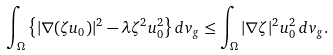Convert formula to latex. <formula><loc_0><loc_0><loc_500><loc_500>\int _ { \Omega } \left \{ | \nabla ( \zeta u _ { 0 } ) | ^ { 2 } - \lambda \zeta ^ { 2 } u _ { 0 } ^ { 2 } \right \} d v _ { g } \leq \int _ { \Omega } | \nabla \zeta | ^ { 2 } u _ { 0 } ^ { 2 } \, d v _ { g } .</formula> 